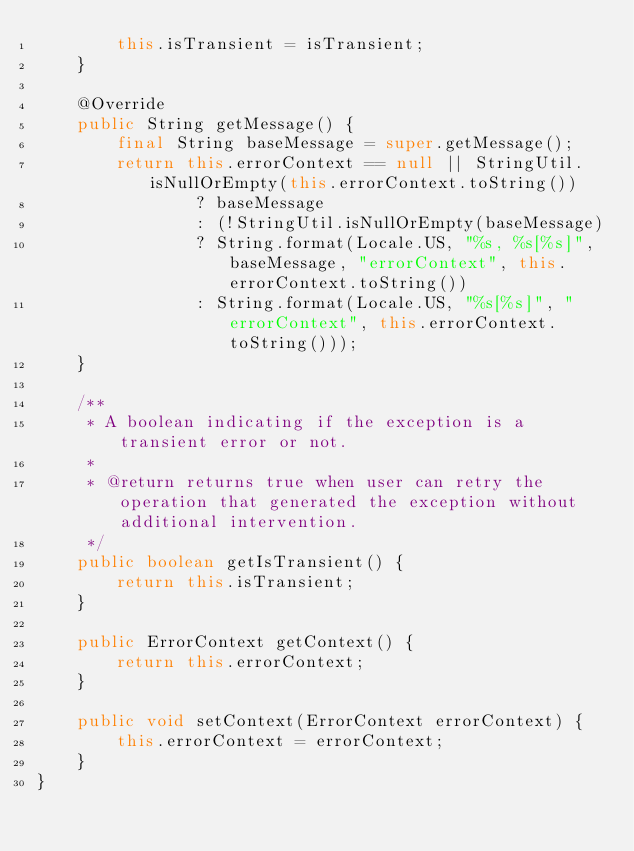Convert code to text. <code><loc_0><loc_0><loc_500><loc_500><_Java_>        this.isTransient = isTransient;
    }

    @Override
    public String getMessage() {
        final String baseMessage = super.getMessage();
        return this.errorContext == null || StringUtil.isNullOrEmpty(this.errorContext.toString())
                ? baseMessage
                : (!StringUtil.isNullOrEmpty(baseMessage)
                ? String.format(Locale.US, "%s, %s[%s]", baseMessage, "errorContext", this.errorContext.toString())
                : String.format(Locale.US, "%s[%s]", "errorContext", this.errorContext.toString()));
    }

    /**
     * A boolean indicating if the exception is a transient error or not.
     *
     * @return returns true when user can retry the operation that generated the exception without additional intervention.
     */
    public boolean getIsTransient() {
        return this.isTransient;
    }

    public ErrorContext getContext() {
        return this.errorContext;
    }

    public void setContext(ErrorContext errorContext) {
        this.errorContext = errorContext;
    }
}
</code> 